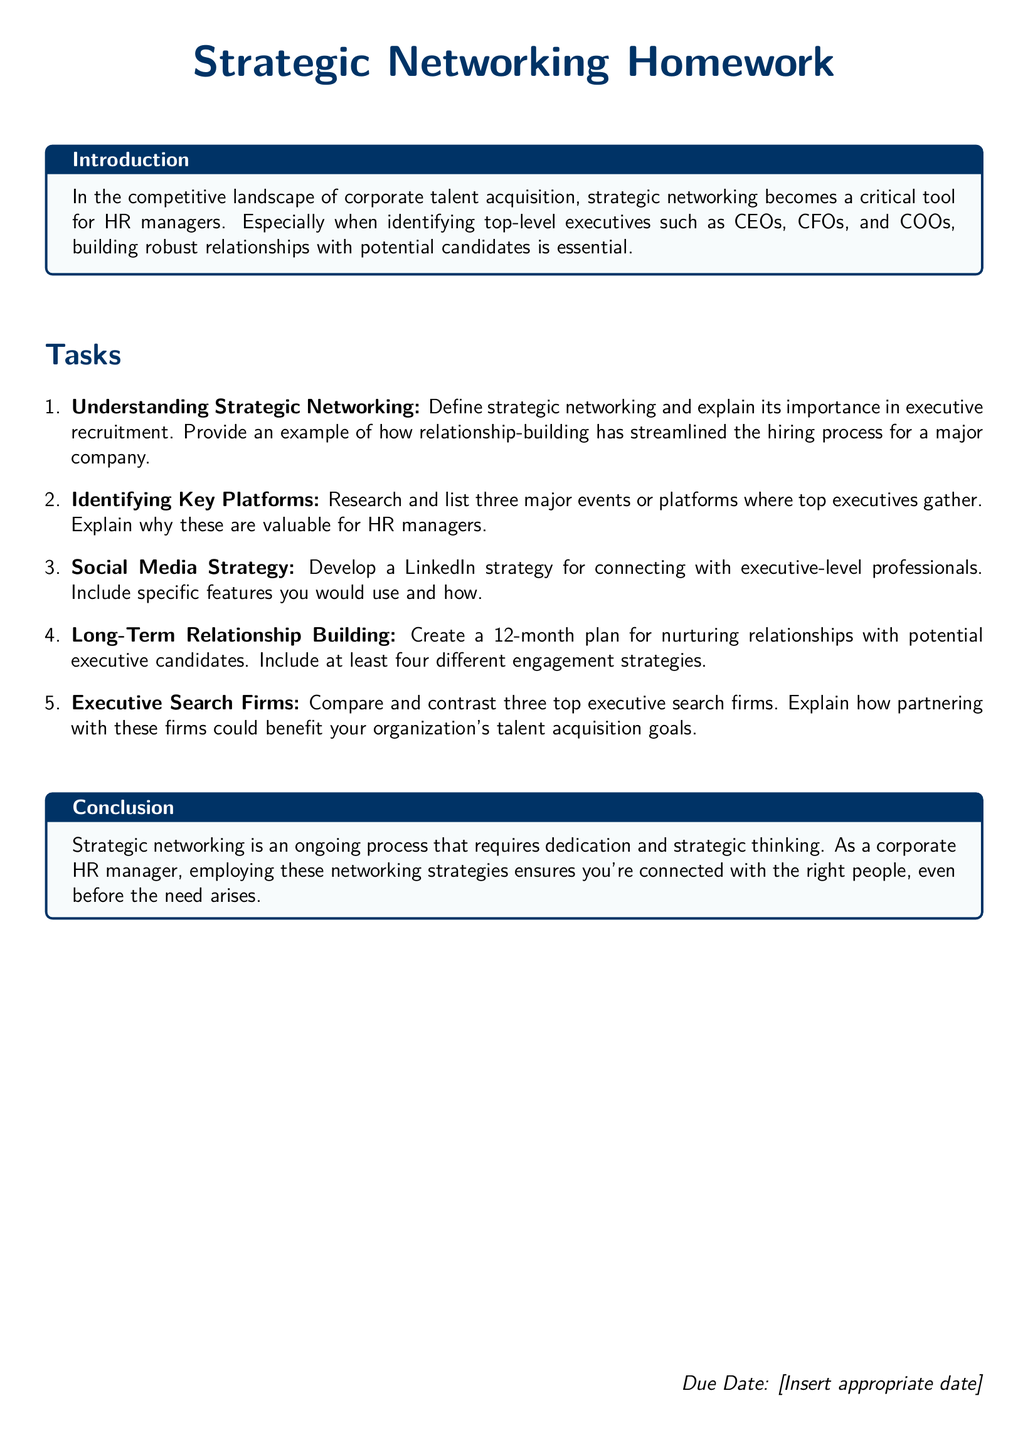what is strategic networking? Strategic networking is defined in the document as a critical tool for HR managers in corporate talent acquisition.
Answer: a critical tool for HR managers what is the focus of the homework document? The focus of the homework document is on strategic networking and building relationships with potential executive candidates.
Answer: strategic networking and building relationships how many tasks are listed in the document? The document lists a total of five tasks for the homework assignment.
Answer: five name one engagement strategy for long-term relationship building. The document specifies four engagement strategies, but does not detail any specific ones in this section.
Answer: not specified what is the due date placeholder in the document? The placeholder for the due date suggests that HR managers should insert an appropriate date for submission.
Answer: [Insert appropriate date] which section discusses the value of executive search firms? The section titled "Executive Search Firms" compares and contrasts three top executive search firms.
Answer: Executive Search Firms what color is used for the box in the introduction? The color used for the box in the introduction is light blue.
Answer: light blue how long is the relationship-building plan? The document specifies that the relationship-building plan should span a duration of 12 months.
Answer: 12 months 